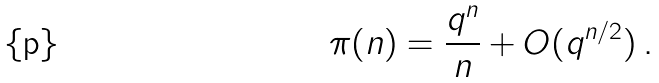<formula> <loc_0><loc_0><loc_500><loc_500>\pi ( n ) = \frac { q ^ { n } } n + O ( q ^ { n / 2 } ) \, .</formula> 